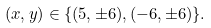<formula> <loc_0><loc_0><loc_500><loc_500>( x , y ) \in \{ ( 5 , \pm 6 ) , ( - 6 , \pm 6 ) \} .</formula> 